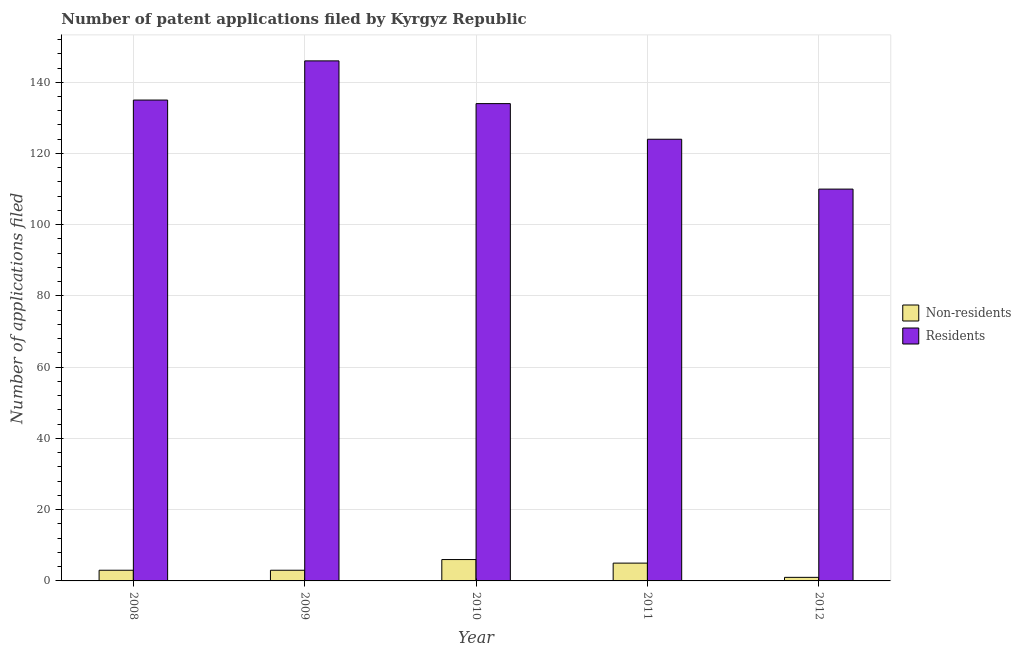How many groups of bars are there?
Offer a very short reply. 5. Are the number of bars on each tick of the X-axis equal?
Your answer should be very brief. Yes. How many bars are there on the 1st tick from the right?
Offer a very short reply. 2. What is the number of patent applications by non residents in 2011?
Keep it short and to the point. 5. Across all years, what is the minimum number of patent applications by residents?
Offer a terse response. 110. What is the total number of patent applications by residents in the graph?
Give a very brief answer. 649. What is the difference between the number of patent applications by residents in 2010 and that in 2011?
Make the answer very short. 10. What is the difference between the number of patent applications by residents in 2011 and the number of patent applications by non residents in 2008?
Ensure brevity in your answer.  -11. What is the average number of patent applications by residents per year?
Keep it short and to the point. 129.8. In the year 2008, what is the difference between the number of patent applications by residents and number of patent applications by non residents?
Your answer should be very brief. 0. In how many years, is the number of patent applications by residents greater than 12?
Make the answer very short. 5. Is the number of patent applications by non residents in 2009 less than that in 2012?
Your answer should be compact. No. What is the difference between the highest and the lowest number of patent applications by non residents?
Offer a very short reply. 5. What does the 1st bar from the left in 2008 represents?
Offer a very short reply. Non-residents. What does the 2nd bar from the right in 2008 represents?
Your answer should be compact. Non-residents. How many bars are there?
Keep it short and to the point. 10. Does the graph contain grids?
Provide a succinct answer. Yes. Where does the legend appear in the graph?
Your response must be concise. Center right. What is the title of the graph?
Your answer should be very brief. Number of patent applications filed by Kyrgyz Republic. What is the label or title of the X-axis?
Give a very brief answer. Year. What is the label or title of the Y-axis?
Ensure brevity in your answer.  Number of applications filed. What is the Number of applications filed of Non-residents in 2008?
Ensure brevity in your answer.  3. What is the Number of applications filed of Residents in 2008?
Provide a succinct answer. 135. What is the Number of applications filed in Non-residents in 2009?
Give a very brief answer. 3. What is the Number of applications filed in Residents in 2009?
Your response must be concise. 146. What is the Number of applications filed of Residents in 2010?
Provide a short and direct response. 134. What is the Number of applications filed in Residents in 2011?
Your answer should be compact. 124. What is the Number of applications filed in Residents in 2012?
Provide a short and direct response. 110. Across all years, what is the maximum Number of applications filed of Residents?
Provide a succinct answer. 146. Across all years, what is the minimum Number of applications filed of Residents?
Ensure brevity in your answer.  110. What is the total Number of applications filed in Residents in the graph?
Your response must be concise. 649. What is the difference between the Number of applications filed in Non-residents in 2008 and that in 2010?
Provide a short and direct response. -3. What is the difference between the Number of applications filed of Residents in 2008 and that in 2010?
Offer a terse response. 1. What is the difference between the Number of applications filed of Non-residents in 2008 and that in 2011?
Make the answer very short. -2. What is the difference between the Number of applications filed in Residents in 2008 and that in 2011?
Give a very brief answer. 11. What is the difference between the Number of applications filed of Non-residents in 2008 and that in 2012?
Provide a short and direct response. 2. What is the difference between the Number of applications filed of Residents in 2008 and that in 2012?
Give a very brief answer. 25. What is the difference between the Number of applications filed in Non-residents in 2009 and that in 2010?
Keep it short and to the point. -3. What is the difference between the Number of applications filed in Residents in 2009 and that in 2010?
Provide a succinct answer. 12. What is the difference between the Number of applications filed of Non-residents in 2009 and that in 2011?
Provide a short and direct response. -2. What is the difference between the Number of applications filed of Residents in 2009 and that in 2011?
Make the answer very short. 22. What is the difference between the Number of applications filed in Non-residents in 2009 and that in 2012?
Your answer should be compact. 2. What is the difference between the Number of applications filed of Non-residents in 2010 and that in 2011?
Your response must be concise. 1. What is the difference between the Number of applications filed of Residents in 2010 and that in 2011?
Your answer should be compact. 10. What is the difference between the Number of applications filed of Non-residents in 2011 and that in 2012?
Provide a succinct answer. 4. What is the difference between the Number of applications filed of Non-residents in 2008 and the Number of applications filed of Residents in 2009?
Provide a short and direct response. -143. What is the difference between the Number of applications filed of Non-residents in 2008 and the Number of applications filed of Residents in 2010?
Give a very brief answer. -131. What is the difference between the Number of applications filed of Non-residents in 2008 and the Number of applications filed of Residents in 2011?
Your response must be concise. -121. What is the difference between the Number of applications filed in Non-residents in 2008 and the Number of applications filed in Residents in 2012?
Provide a succinct answer. -107. What is the difference between the Number of applications filed in Non-residents in 2009 and the Number of applications filed in Residents in 2010?
Provide a short and direct response. -131. What is the difference between the Number of applications filed in Non-residents in 2009 and the Number of applications filed in Residents in 2011?
Your answer should be very brief. -121. What is the difference between the Number of applications filed in Non-residents in 2009 and the Number of applications filed in Residents in 2012?
Provide a succinct answer. -107. What is the difference between the Number of applications filed of Non-residents in 2010 and the Number of applications filed of Residents in 2011?
Ensure brevity in your answer.  -118. What is the difference between the Number of applications filed in Non-residents in 2010 and the Number of applications filed in Residents in 2012?
Your answer should be compact. -104. What is the difference between the Number of applications filed of Non-residents in 2011 and the Number of applications filed of Residents in 2012?
Keep it short and to the point. -105. What is the average Number of applications filed in Non-residents per year?
Your response must be concise. 3.6. What is the average Number of applications filed of Residents per year?
Give a very brief answer. 129.8. In the year 2008, what is the difference between the Number of applications filed of Non-residents and Number of applications filed of Residents?
Offer a very short reply. -132. In the year 2009, what is the difference between the Number of applications filed of Non-residents and Number of applications filed of Residents?
Your answer should be very brief. -143. In the year 2010, what is the difference between the Number of applications filed in Non-residents and Number of applications filed in Residents?
Offer a terse response. -128. In the year 2011, what is the difference between the Number of applications filed of Non-residents and Number of applications filed of Residents?
Your response must be concise. -119. In the year 2012, what is the difference between the Number of applications filed of Non-residents and Number of applications filed of Residents?
Give a very brief answer. -109. What is the ratio of the Number of applications filed of Non-residents in 2008 to that in 2009?
Keep it short and to the point. 1. What is the ratio of the Number of applications filed in Residents in 2008 to that in 2009?
Ensure brevity in your answer.  0.92. What is the ratio of the Number of applications filed in Non-residents in 2008 to that in 2010?
Give a very brief answer. 0.5. What is the ratio of the Number of applications filed in Residents in 2008 to that in 2010?
Ensure brevity in your answer.  1.01. What is the ratio of the Number of applications filed of Residents in 2008 to that in 2011?
Give a very brief answer. 1.09. What is the ratio of the Number of applications filed of Non-residents in 2008 to that in 2012?
Provide a succinct answer. 3. What is the ratio of the Number of applications filed of Residents in 2008 to that in 2012?
Offer a very short reply. 1.23. What is the ratio of the Number of applications filed of Non-residents in 2009 to that in 2010?
Your answer should be compact. 0.5. What is the ratio of the Number of applications filed of Residents in 2009 to that in 2010?
Offer a very short reply. 1.09. What is the ratio of the Number of applications filed of Residents in 2009 to that in 2011?
Your answer should be compact. 1.18. What is the ratio of the Number of applications filed in Residents in 2009 to that in 2012?
Make the answer very short. 1.33. What is the ratio of the Number of applications filed in Residents in 2010 to that in 2011?
Provide a short and direct response. 1.08. What is the ratio of the Number of applications filed in Residents in 2010 to that in 2012?
Provide a succinct answer. 1.22. What is the ratio of the Number of applications filed in Non-residents in 2011 to that in 2012?
Your response must be concise. 5. What is the ratio of the Number of applications filed in Residents in 2011 to that in 2012?
Keep it short and to the point. 1.13. What is the difference between the highest and the second highest Number of applications filed of Residents?
Your answer should be very brief. 11. What is the difference between the highest and the lowest Number of applications filed in Non-residents?
Offer a very short reply. 5. 